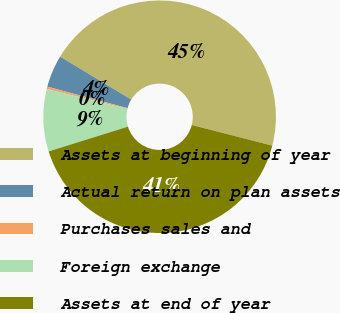Convert chart to OTSL. <chart><loc_0><loc_0><loc_500><loc_500><pie_chart><fcel>Assets at beginning of year<fcel>Actual return on plan assets<fcel>Purchases sales and<fcel>Foreign exchange<fcel>Assets at end of year<nl><fcel>45.34%<fcel>4.49%<fcel>0.33%<fcel>8.65%<fcel>41.19%<nl></chart> 